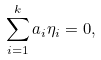Convert formula to latex. <formula><loc_0><loc_0><loc_500><loc_500>\sum _ { i = 1 } ^ { k } a _ { i } \eta _ { i } = 0 ,</formula> 